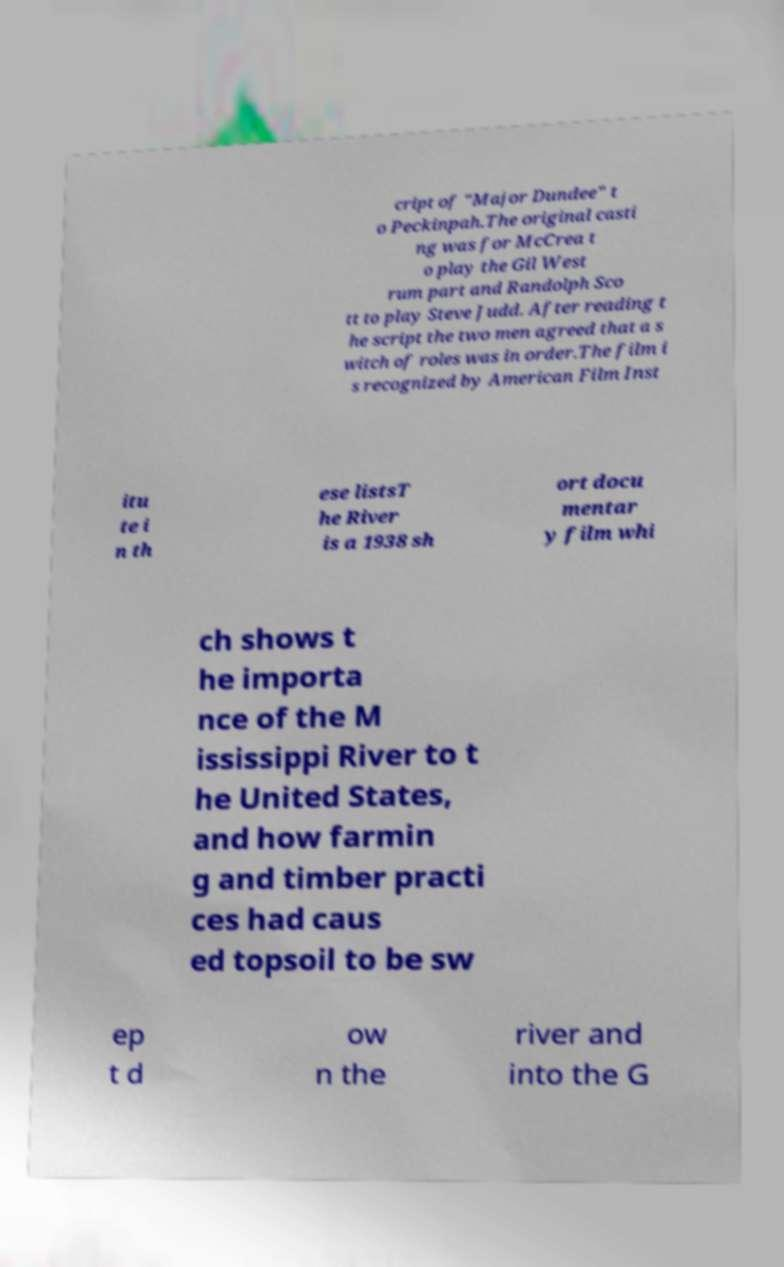There's text embedded in this image that I need extracted. Can you transcribe it verbatim? cript of "Major Dundee" t o Peckinpah.The original casti ng was for McCrea t o play the Gil West rum part and Randolph Sco tt to play Steve Judd. After reading t he script the two men agreed that a s witch of roles was in order.The film i s recognized by American Film Inst itu te i n th ese listsT he River is a 1938 sh ort docu mentar y film whi ch shows t he importa nce of the M ississippi River to t he United States, and how farmin g and timber practi ces had caus ed topsoil to be sw ep t d ow n the river and into the G 